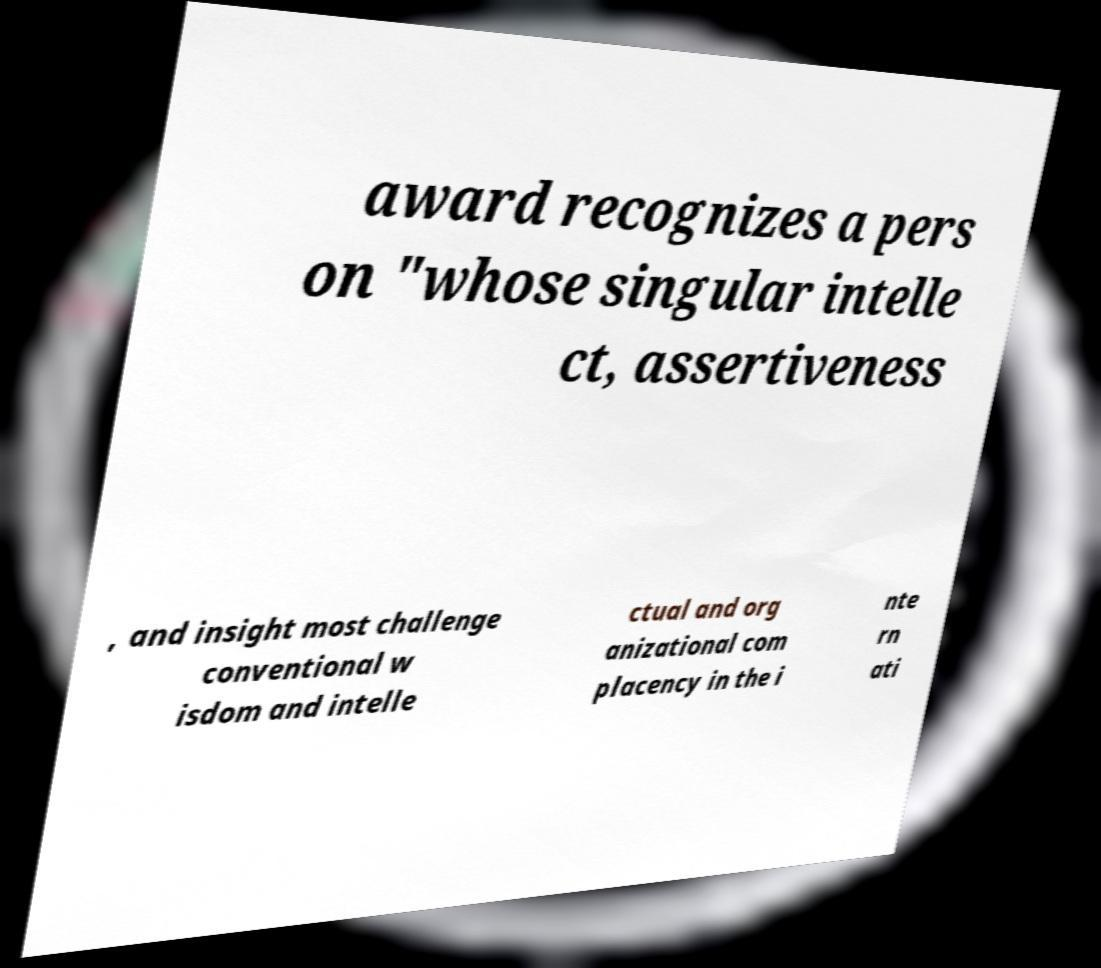There's text embedded in this image that I need extracted. Can you transcribe it verbatim? award recognizes a pers on "whose singular intelle ct, assertiveness , and insight most challenge conventional w isdom and intelle ctual and org anizational com placency in the i nte rn ati 